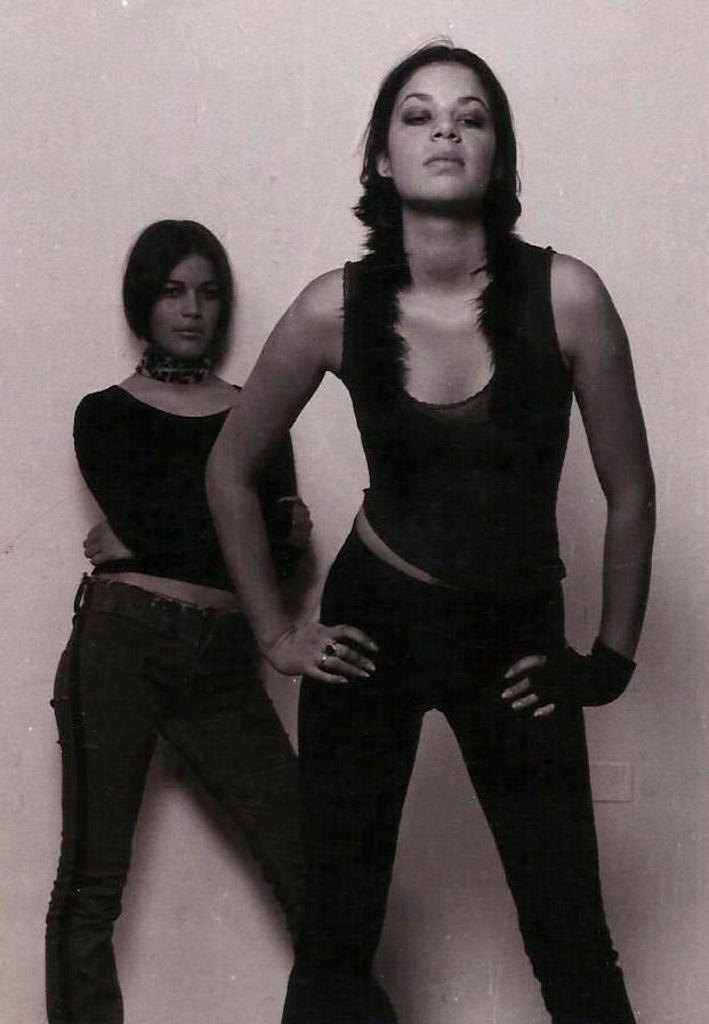How many women are in the image? There are two women in the image. What are the women doing in the image? The women are standing in the image. What are the women wearing in the image? The women are wearing black dresses in the image. What can be seen in the background of the image? There is a well in the background of the image. What type of seat can be seen in the image? There is no seat present in the image. What color is the silver object in the image? There is no silver object present in the image. 